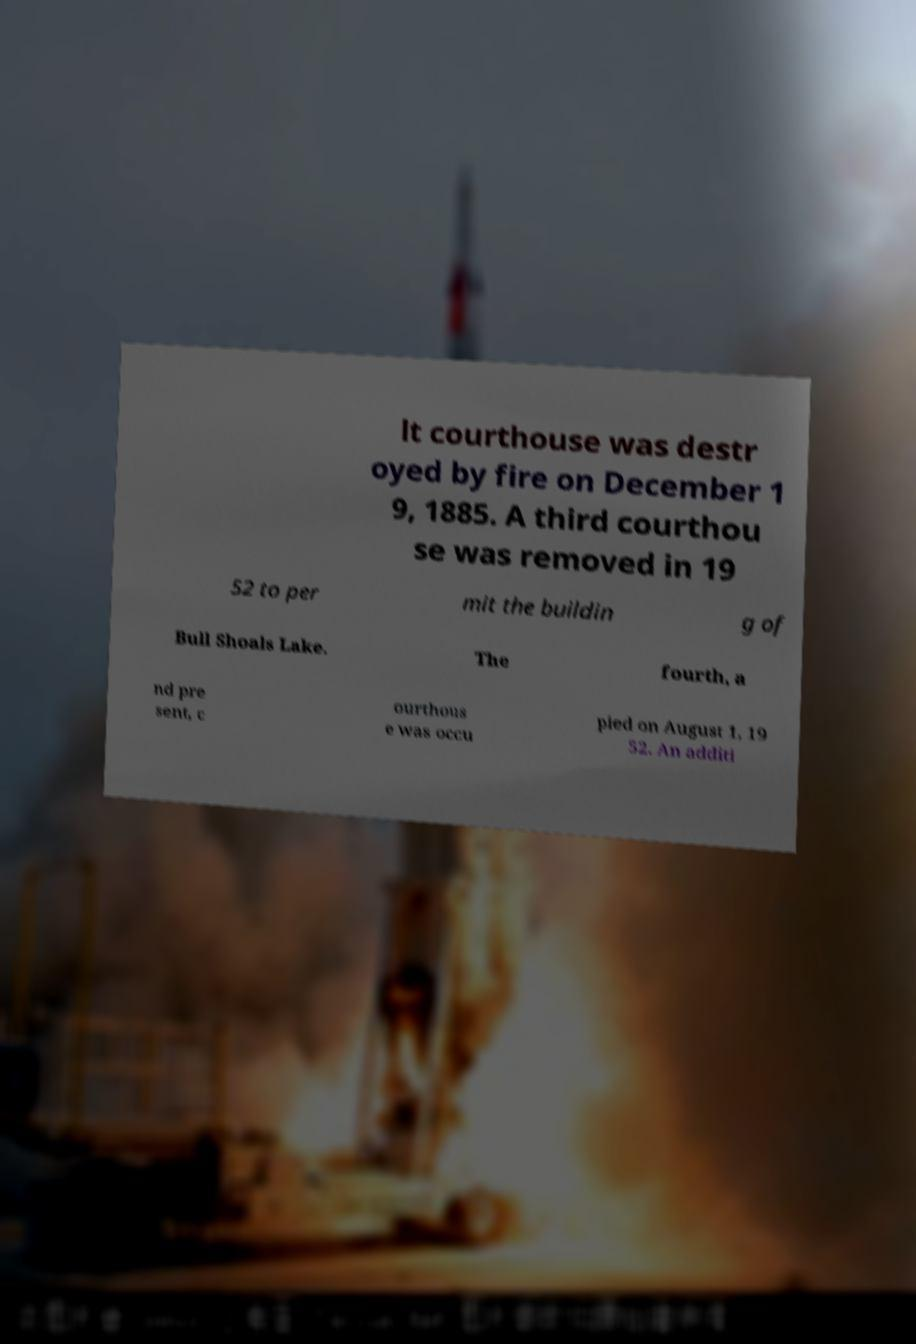Could you assist in decoding the text presented in this image and type it out clearly? lt courthouse was destr oyed by fire on December 1 9, 1885. A third courthou se was removed in 19 52 to per mit the buildin g of Bull Shoals Lake. The fourth, a nd pre sent, c ourthous e was occu pied on August 1, 19 52. An additi 